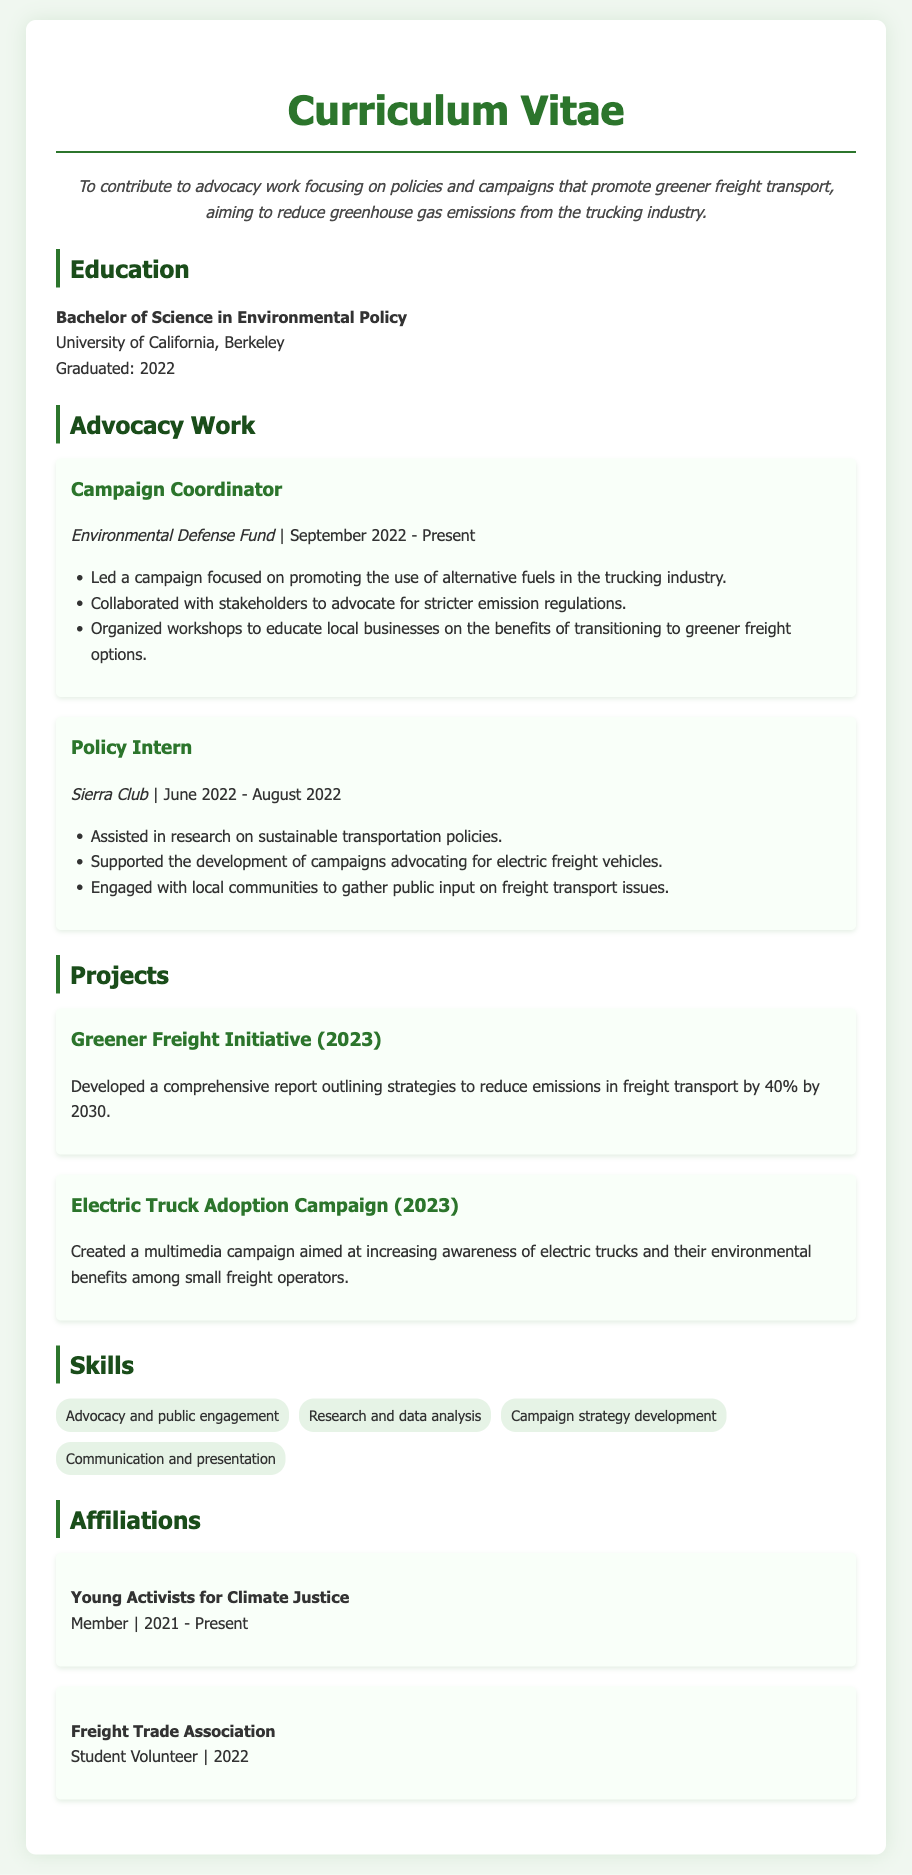What is the name of the university the individual attended? The individual's education includes a Bachelor of Science degree from the University of California, Berkeley.
Answer: University of California, Berkeley What role does the individual currently hold? The individual is currently a Campaign Coordinator at the Environmental Defense Fund.
Answer: Campaign Coordinator When did the individual start their current position? The current position at the Environmental Defense Fund started in September 2022.
Answer: September 2022 What is the main focus of the Greener Freight Initiative project? The Greener Freight Initiative aims to reduce emissions in freight transport by 40% by 2030.
Answer: Reduce emissions by 40% by 2030 Which organization did the individual intern for in 2022? The individual was a Policy Intern at the Sierra Club.
Answer: Sierra Club What type of campaign did the individual create for small freight operators? The individual created a multimedia campaign to increase awareness of electric trucks.
Answer: Multimedia campaign What is one specific skill listed in the document? One specific skill included in the skills section is research and data analysis.
Answer: Research and data analysis Which advocacy organization is the individual a member of? The individual is a member of Young Activists for Climate Justice.
Answer: Young Activists for Climate Justice 